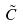<formula> <loc_0><loc_0><loc_500><loc_500>\tilde { C }</formula> 